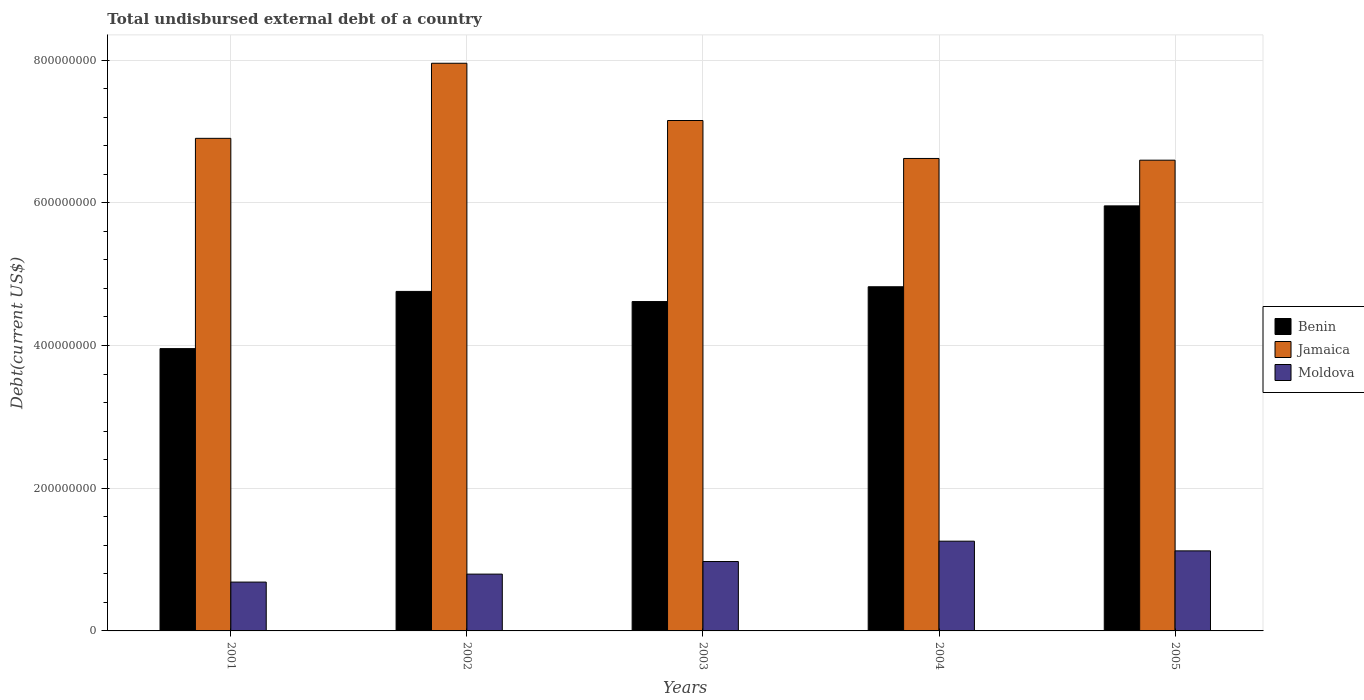How many groups of bars are there?
Ensure brevity in your answer.  5. Are the number of bars per tick equal to the number of legend labels?
Give a very brief answer. Yes. Are the number of bars on each tick of the X-axis equal?
Give a very brief answer. Yes. How many bars are there on the 4th tick from the right?
Give a very brief answer. 3. In how many cases, is the number of bars for a given year not equal to the number of legend labels?
Provide a succinct answer. 0. What is the total undisbursed external debt in Jamaica in 2004?
Provide a succinct answer. 6.62e+08. Across all years, what is the maximum total undisbursed external debt in Benin?
Offer a terse response. 5.96e+08. Across all years, what is the minimum total undisbursed external debt in Jamaica?
Your response must be concise. 6.60e+08. In which year was the total undisbursed external debt in Jamaica maximum?
Provide a short and direct response. 2002. In which year was the total undisbursed external debt in Benin minimum?
Your response must be concise. 2001. What is the total total undisbursed external debt in Jamaica in the graph?
Keep it short and to the point. 3.52e+09. What is the difference between the total undisbursed external debt in Moldova in 2001 and that in 2004?
Provide a short and direct response. -5.73e+07. What is the difference between the total undisbursed external debt in Benin in 2003 and the total undisbursed external debt in Moldova in 2005?
Your answer should be compact. 3.49e+08. What is the average total undisbursed external debt in Jamaica per year?
Provide a short and direct response. 7.05e+08. In the year 2001, what is the difference between the total undisbursed external debt in Moldova and total undisbursed external debt in Jamaica?
Offer a terse response. -6.22e+08. In how many years, is the total undisbursed external debt in Moldova greater than 440000000 US$?
Ensure brevity in your answer.  0. What is the ratio of the total undisbursed external debt in Benin in 2003 to that in 2004?
Your answer should be compact. 0.96. Is the difference between the total undisbursed external debt in Moldova in 2001 and 2004 greater than the difference between the total undisbursed external debt in Jamaica in 2001 and 2004?
Your answer should be very brief. No. What is the difference between the highest and the second highest total undisbursed external debt in Moldova?
Offer a terse response. 1.36e+07. What is the difference between the highest and the lowest total undisbursed external debt in Jamaica?
Make the answer very short. 1.36e+08. In how many years, is the total undisbursed external debt in Benin greater than the average total undisbursed external debt in Benin taken over all years?
Your response must be concise. 2. What does the 2nd bar from the left in 2004 represents?
Ensure brevity in your answer.  Jamaica. What does the 2nd bar from the right in 2004 represents?
Keep it short and to the point. Jamaica. How many bars are there?
Offer a very short reply. 15. Are all the bars in the graph horizontal?
Your answer should be very brief. No. How many years are there in the graph?
Offer a very short reply. 5. What is the difference between two consecutive major ticks on the Y-axis?
Keep it short and to the point. 2.00e+08. Where does the legend appear in the graph?
Your answer should be compact. Center right. How are the legend labels stacked?
Provide a short and direct response. Vertical. What is the title of the graph?
Offer a terse response. Total undisbursed external debt of a country. Does "Vanuatu" appear as one of the legend labels in the graph?
Your answer should be compact. No. What is the label or title of the Y-axis?
Ensure brevity in your answer.  Debt(current US$). What is the Debt(current US$) in Benin in 2001?
Offer a very short reply. 3.96e+08. What is the Debt(current US$) in Jamaica in 2001?
Give a very brief answer. 6.90e+08. What is the Debt(current US$) of Moldova in 2001?
Provide a short and direct response. 6.85e+07. What is the Debt(current US$) of Benin in 2002?
Make the answer very short. 4.76e+08. What is the Debt(current US$) in Jamaica in 2002?
Provide a succinct answer. 7.96e+08. What is the Debt(current US$) in Moldova in 2002?
Keep it short and to the point. 7.96e+07. What is the Debt(current US$) of Benin in 2003?
Offer a terse response. 4.62e+08. What is the Debt(current US$) of Jamaica in 2003?
Your response must be concise. 7.15e+08. What is the Debt(current US$) in Moldova in 2003?
Give a very brief answer. 9.73e+07. What is the Debt(current US$) of Benin in 2004?
Offer a terse response. 4.82e+08. What is the Debt(current US$) in Jamaica in 2004?
Ensure brevity in your answer.  6.62e+08. What is the Debt(current US$) in Moldova in 2004?
Offer a very short reply. 1.26e+08. What is the Debt(current US$) of Benin in 2005?
Offer a very short reply. 5.96e+08. What is the Debt(current US$) in Jamaica in 2005?
Offer a very short reply. 6.60e+08. What is the Debt(current US$) of Moldova in 2005?
Your answer should be very brief. 1.12e+08. Across all years, what is the maximum Debt(current US$) in Benin?
Your answer should be very brief. 5.96e+08. Across all years, what is the maximum Debt(current US$) in Jamaica?
Make the answer very short. 7.96e+08. Across all years, what is the maximum Debt(current US$) of Moldova?
Offer a very short reply. 1.26e+08. Across all years, what is the minimum Debt(current US$) in Benin?
Your response must be concise. 3.96e+08. Across all years, what is the minimum Debt(current US$) in Jamaica?
Give a very brief answer. 6.60e+08. Across all years, what is the minimum Debt(current US$) of Moldova?
Provide a short and direct response. 6.85e+07. What is the total Debt(current US$) in Benin in the graph?
Make the answer very short. 2.41e+09. What is the total Debt(current US$) in Jamaica in the graph?
Give a very brief answer. 3.52e+09. What is the total Debt(current US$) of Moldova in the graph?
Your answer should be compact. 4.83e+08. What is the difference between the Debt(current US$) of Benin in 2001 and that in 2002?
Your answer should be very brief. -8.02e+07. What is the difference between the Debt(current US$) in Jamaica in 2001 and that in 2002?
Your answer should be very brief. -1.05e+08. What is the difference between the Debt(current US$) of Moldova in 2001 and that in 2002?
Give a very brief answer. -1.12e+07. What is the difference between the Debt(current US$) of Benin in 2001 and that in 2003?
Give a very brief answer. -6.60e+07. What is the difference between the Debt(current US$) in Jamaica in 2001 and that in 2003?
Keep it short and to the point. -2.50e+07. What is the difference between the Debt(current US$) of Moldova in 2001 and that in 2003?
Offer a very short reply. -2.88e+07. What is the difference between the Debt(current US$) of Benin in 2001 and that in 2004?
Your response must be concise. -8.67e+07. What is the difference between the Debt(current US$) in Jamaica in 2001 and that in 2004?
Offer a very short reply. 2.82e+07. What is the difference between the Debt(current US$) in Moldova in 2001 and that in 2004?
Your response must be concise. -5.73e+07. What is the difference between the Debt(current US$) in Benin in 2001 and that in 2005?
Ensure brevity in your answer.  -2.00e+08. What is the difference between the Debt(current US$) in Jamaica in 2001 and that in 2005?
Make the answer very short. 3.06e+07. What is the difference between the Debt(current US$) of Moldova in 2001 and that in 2005?
Your response must be concise. -4.37e+07. What is the difference between the Debt(current US$) in Benin in 2002 and that in 2003?
Provide a short and direct response. 1.42e+07. What is the difference between the Debt(current US$) of Jamaica in 2002 and that in 2003?
Make the answer very short. 8.02e+07. What is the difference between the Debt(current US$) of Moldova in 2002 and that in 2003?
Make the answer very short. -1.76e+07. What is the difference between the Debt(current US$) in Benin in 2002 and that in 2004?
Keep it short and to the point. -6.52e+06. What is the difference between the Debt(current US$) in Jamaica in 2002 and that in 2004?
Offer a terse response. 1.33e+08. What is the difference between the Debt(current US$) of Moldova in 2002 and that in 2004?
Offer a terse response. -4.62e+07. What is the difference between the Debt(current US$) of Benin in 2002 and that in 2005?
Provide a short and direct response. -1.20e+08. What is the difference between the Debt(current US$) in Jamaica in 2002 and that in 2005?
Give a very brief answer. 1.36e+08. What is the difference between the Debt(current US$) in Moldova in 2002 and that in 2005?
Ensure brevity in your answer.  -3.26e+07. What is the difference between the Debt(current US$) in Benin in 2003 and that in 2004?
Your response must be concise. -2.07e+07. What is the difference between the Debt(current US$) of Jamaica in 2003 and that in 2004?
Give a very brief answer. 5.32e+07. What is the difference between the Debt(current US$) in Moldova in 2003 and that in 2004?
Your response must be concise. -2.85e+07. What is the difference between the Debt(current US$) in Benin in 2003 and that in 2005?
Your answer should be compact. -1.34e+08. What is the difference between the Debt(current US$) of Jamaica in 2003 and that in 2005?
Ensure brevity in your answer.  5.56e+07. What is the difference between the Debt(current US$) in Moldova in 2003 and that in 2005?
Offer a very short reply. -1.49e+07. What is the difference between the Debt(current US$) in Benin in 2004 and that in 2005?
Make the answer very short. -1.13e+08. What is the difference between the Debt(current US$) of Jamaica in 2004 and that in 2005?
Offer a terse response. 2.42e+06. What is the difference between the Debt(current US$) in Moldova in 2004 and that in 2005?
Give a very brief answer. 1.36e+07. What is the difference between the Debt(current US$) of Benin in 2001 and the Debt(current US$) of Jamaica in 2002?
Your answer should be very brief. -4.00e+08. What is the difference between the Debt(current US$) in Benin in 2001 and the Debt(current US$) in Moldova in 2002?
Your answer should be very brief. 3.16e+08. What is the difference between the Debt(current US$) in Jamaica in 2001 and the Debt(current US$) in Moldova in 2002?
Your answer should be very brief. 6.11e+08. What is the difference between the Debt(current US$) in Benin in 2001 and the Debt(current US$) in Jamaica in 2003?
Your response must be concise. -3.20e+08. What is the difference between the Debt(current US$) of Benin in 2001 and the Debt(current US$) of Moldova in 2003?
Offer a very short reply. 2.98e+08. What is the difference between the Debt(current US$) in Jamaica in 2001 and the Debt(current US$) in Moldova in 2003?
Your response must be concise. 5.93e+08. What is the difference between the Debt(current US$) in Benin in 2001 and the Debt(current US$) in Jamaica in 2004?
Offer a terse response. -2.67e+08. What is the difference between the Debt(current US$) in Benin in 2001 and the Debt(current US$) in Moldova in 2004?
Give a very brief answer. 2.70e+08. What is the difference between the Debt(current US$) of Jamaica in 2001 and the Debt(current US$) of Moldova in 2004?
Offer a terse response. 5.65e+08. What is the difference between the Debt(current US$) in Benin in 2001 and the Debt(current US$) in Jamaica in 2005?
Offer a terse response. -2.64e+08. What is the difference between the Debt(current US$) in Benin in 2001 and the Debt(current US$) in Moldova in 2005?
Give a very brief answer. 2.83e+08. What is the difference between the Debt(current US$) in Jamaica in 2001 and the Debt(current US$) in Moldova in 2005?
Your response must be concise. 5.78e+08. What is the difference between the Debt(current US$) in Benin in 2002 and the Debt(current US$) in Jamaica in 2003?
Offer a terse response. -2.40e+08. What is the difference between the Debt(current US$) in Benin in 2002 and the Debt(current US$) in Moldova in 2003?
Keep it short and to the point. 3.79e+08. What is the difference between the Debt(current US$) in Jamaica in 2002 and the Debt(current US$) in Moldova in 2003?
Offer a terse response. 6.98e+08. What is the difference between the Debt(current US$) of Benin in 2002 and the Debt(current US$) of Jamaica in 2004?
Your answer should be very brief. -1.86e+08. What is the difference between the Debt(current US$) in Benin in 2002 and the Debt(current US$) in Moldova in 2004?
Offer a very short reply. 3.50e+08. What is the difference between the Debt(current US$) of Jamaica in 2002 and the Debt(current US$) of Moldova in 2004?
Your response must be concise. 6.70e+08. What is the difference between the Debt(current US$) of Benin in 2002 and the Debt(current US$) of Jamaica in 2005?
Your answer should be compact. -1.84e+08. What is the difference between the Debt(current US$) of Benin in 2002 and the Debt(current US$) of Moldova in 2005?
Provide a short and direct response. 3.64e+08. What is the difference between the Debt(current US$) of Jamaica in 2002 and the Debt(current US$) of Moldova in 2005?
Keep it short and to the point. 6.83e+08. What is the difference between the Debt(current US$) in Benin in 2003 and the Debt(current US$) in Jamaica in 2004?
Your answer should be compact. -2.01e+08. What is the difference between the Debt(current US$) of Benin in 2003 and the Debt(current US$) of Moldova in 2004?
Your answer should be compact. 3.36e+08. What is the difference between the Debt(current US$) in Jamaica in 2003 and the Debt(current US$) in Moldova in 2004?
Provide a succinct answer. 5.90e+08. What is the difference between the Debt(current US$) in Benin in 2003 and the Debt(current US$) in Jamaica in 2005?
Make the answer very short. -1.98e+08. What is the difference between the Debt(current US$) in Benin in 2003 and the Debt(current US$) in Moldova in 2005?
Your response must be concise. 3.49e+08. What is the difference between the Debt(current US$) of Jamaica in 2003 and the Debt(current US$) of Moldova in 2005?
Offer a very short reply. 6.03e+08. What is the difference between the Debt(current US$) in Benin in 2004 and the Debt(current US$) in Jamaica in 2005?
Ensure brevity in your answer.  -1.77e+08. What is the difference between the Debt(current US$) in Benin in 2004 and the Debt(current US$) in Moldova in 2005?
Offer a very short reply. 3.70e+08. What is the difference between the Debt(current US$) in Jamaica in 2004 and the Debt(current US$) in Moldova in 2005?
Make the answer very short. 5.50e+08. What is the average Debt(current US$) in Benin per year?
Ensure brevity in your answer.  4.82e+08. What is the average Debt(current US$) of Jamaica per year?
Your response must be concise. 7.05e+08. What is the average Debt(current US$) in Moldova per year?
Offer a terse response. 9.67e+07. In the year 2001, what is the difference between the Debt(current US$) in Benin and Debt(current US$) in Jamaica?
Make the answer very short. -2.95e+08. In the year 2001, what is the difference between the Debt(current US$) in Benin and Debt(current US$) in Moldova?
Your answer should be compact. 3.27e+08. In the year 2001, what is the difference between the Debt(current US$) of Jamaica and Debt(current US$) of Moldova?
Provide a short and direct response. 6.22e+08. In the year 2002, what is the difference between the Debt(current US$) in Benin and Debt(current US$) in Jamaica?
Keep it short and to the point. -3.20e+08. In the year 2002, what is the difference between the Debt(current US$) in Benin and Debt(current US$) in Moldova?
Offer a very short reply. 3.96e+08. In the year 2002, what is the difference between the Debt(current US$) in Jamaica and Debt(current US$) in Moldova?
Offer a very short reply. 7.16e+08. In the year 2003, what is the difference between the Debt(current US$) of Benin and Debt(current US$) of Jamaica?
Provide a succinct answer. -2.54e+08. In the year 2003, what is the difference between the Debt(current US$) of Benin and Debt(current US$) of Moldova?
Give a very brief answer. 3.64e+08. In the year 2003, what is the difference between the Debt(current US$) in Jamaica and Debt(current US$) in Moldova?
Make the answer very short. 6.18e+08. In the year 2004, what is the difference between the Debt(current US$) of Benin and Debt(current US$) of Jamaica?
Provide a succinct answer. -1.80e+08. In the year 2004, what is the difference between the Debt(current US$) in Benin and Debt(current US$) in Moldova?
Provide a succinct answer. 3.57e+08. In the year 2004, what is the difference between the Debt(current US$) of Jamaica and Debt(current US$) of Moldova?
Give a very brief answer. 5.36e+08. In the year 2005, what is the difference between the Debt(current US$) of Benin and Debt(current US$) of Jamaica?
Ensure brevity in your answer.  -6.40e+07. In the year 2005, what is the difference between the Debt(current US$) in Benin and Debt(current US$) in Moldova?
Offer a very short reply. 4.84e+08. In the year 2005, what is the difference between the Debt(current US$) in Jamaica and Debt(current US$) in Moldova?
Make the answer very short. 5.48e+08. What is the ratio of the Debt(current US$) of Benin in 2001 to that in 2002?
Your answer should be very brief. 0.83. What is the ratio of the Debt(current US$) of Jamaica in 2001 to that in 2002?
Provide a short and direct response. 0.87. What is the ratio of the Debt(current US$) in Moldova in 2001 to that in 2002?
Keep it short and to the point. 0.86. What is the ratio of the Debt(current US$) of Benin in 2001 to that in 2003?
Provide a short and direct response. 0.86. What is the ratio of the Debt(current US$) in Jamaica in 2001 to that in 2003?
Ensure brevity in your answer.  0.97. What is the ratio of the Debt(current US$) of Moldova in 2001 to that in 2003?
Provide a short and direct response. 0.7. What is the ratio of the Debt(current US$) of Benin in 2001 to that in 2004?
Ensure brevity in your answer.  0.82. What is the ratio of the Debt(current US$) in Jamaica in 2001 to that in 2004?
Make the answer very short. 1.04. What is the ratio of the Debt(current US$) of Moldova in 2001 to that in 2004?
Your answer should be compact. 0.54. What is the ratio of the Debt(current US$) in Benin in 2001 to that in 2005?
Your answer should be compact. 0.66. What is the ratio of the Debt(current US$) in Jamaica in 2001 to that in 2005?
Give a very brief answer. 1.05. What is the ratio of the Debt(current US$) of Moldova in 2001 to that in 2005?
Make the answer very short. 0.61. What is the ratio of the Debt(current US$) of Benin in 2002 to that in 2003?
Offer a very short reply. 1.03. What is the ratio of the Debt(current US$) in Jamaica in 2002 to that in 2003?
Provide a succinct answer. 1.11. What is the ratio of the Debt(current US$) in Moldova in 2002 to that in 2003?
Provide a short and direct response. 0.82. What is the ratio of the Debt(current US$) in Benin in 2002 to that in 2004?
Provide a succinct answer. 0.99. What is the ratio of the Debt(current US$) in Jamaica in 2002 to that in 2004?
Your response must be concise. 1.2. What is the ratio of the Debt(current US$) in Moldova in 2002 to that in 2004?
Your answer should be compact. 0.63. What is the ratio of the Debt(current US$) of Benin in 2002 to that in 2005?
Your answer should be very brief. 0.8. What is the ratio of the Debt(current US$) in Jamaica in 2002 to that in 2005?
Your answer should be very brief. 1.21. What is the ratio of the Debt(current US$) in Moldova in 2002 to that in 2005?
Your response must be concise. 0.71. What is the ratio of the Debt(current US$) of Benin in 2003 to that in 2004?
Ensure brevity in your answer.  0.96. What is the ratio of the Debt(current US$) of Jamaica in 2003 to that in 2004?
Offer a terse response. 1.08. What is the ratio of the Debt(current US$) of Moldova in 2003 to that in 2004?
Your response must be concise. 0.77. What is the ratio of the Debt(current US$) of Benin in 2003 to that in 2005?
Keep it short and to the point. 0.77. What is the ratio of the Debt(current US$) of Jamaica in 2003 to that in 2005?
Your response must be concise. 1.08. What is the ratio of the Debt(current US$) of Moldova in 2003 to that in 2005?
Ensure brevity in your answer.  0.87. What is the ratio of the Debt(current US$) of Benin in 2004 to that in 2005?
Ensure brevity in your answer.  0.81. What is the ratio of the Debt(current US$) in Jamaica in 2004 to that in 2005?
Provide a succinct answer. 1. What is the ratio of the Debt(current US$) in Moldova in 2004 to that in 2005?
Provide a succinct answer. 1.12. What is the difference between the highest and the second highest Debt(current US$) of Benin?
Provide a short and direct response. 1.13e+08. What is the difference between the highest and the second highest Debt(current US$) in Jamaica?
Offer a terse response. 8.02e+07. What is the difference between the highest and the second highest Debt(current US$) in Moldova?
Keep it short and to the point. 1.36e+07. What is the difference between the highest and the lowest Debt(current US$) of Benin?
Offer a terse response. 2.00e+08. What is the difference between the highest and the lowest Debt(current US$) of Jamaica?
Your answer should be compact. 1.36e+08. What is the difference between the highest and the lowest Debt(current US$) in Moldova?
Your response must be concise. 5.73e+07. 